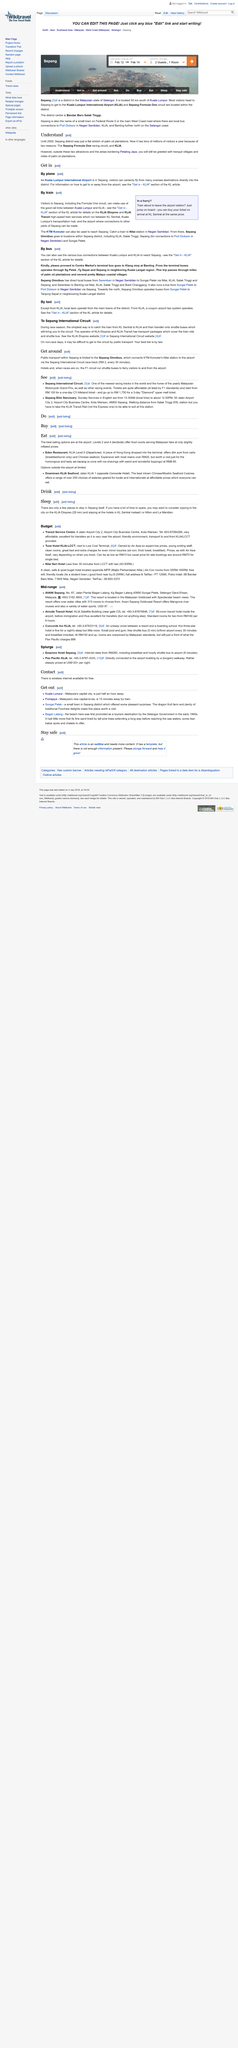Point out several critical features in this image. Kuala Lumpur International Airport is located in Sepang, Malaysia. The Sepang district attracts millions of visitors every year, primarily due to the existence of the Sepang Formula One racing circuit and the Kuala Lumpur International Airport (KLIA). The Sepang region attracts visitors with its Formula One racing circuit, KLIA, peaceful villages, and lush palm oil plantations. 